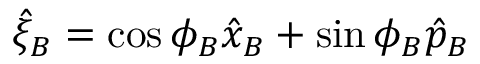<formula> <loc_0><loc_0><loc_500><loc_500>\hat { \xi } _ { B } = \cos \phi _ { B } \hat { x } _ { B } + \sin \phi _ { B } \hat { p } _ { B }</formula> 